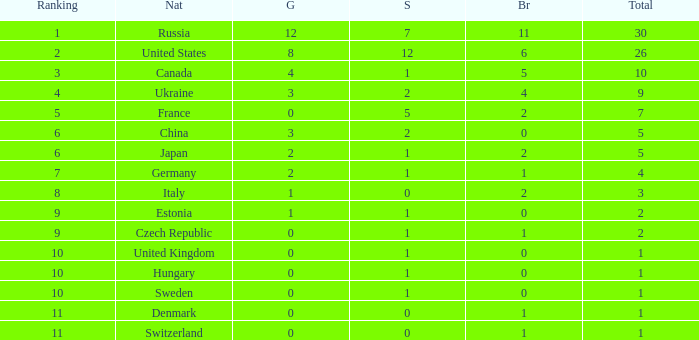How many silvers have a Nation of hungary, and a Rank larger than 10? 0.0. 